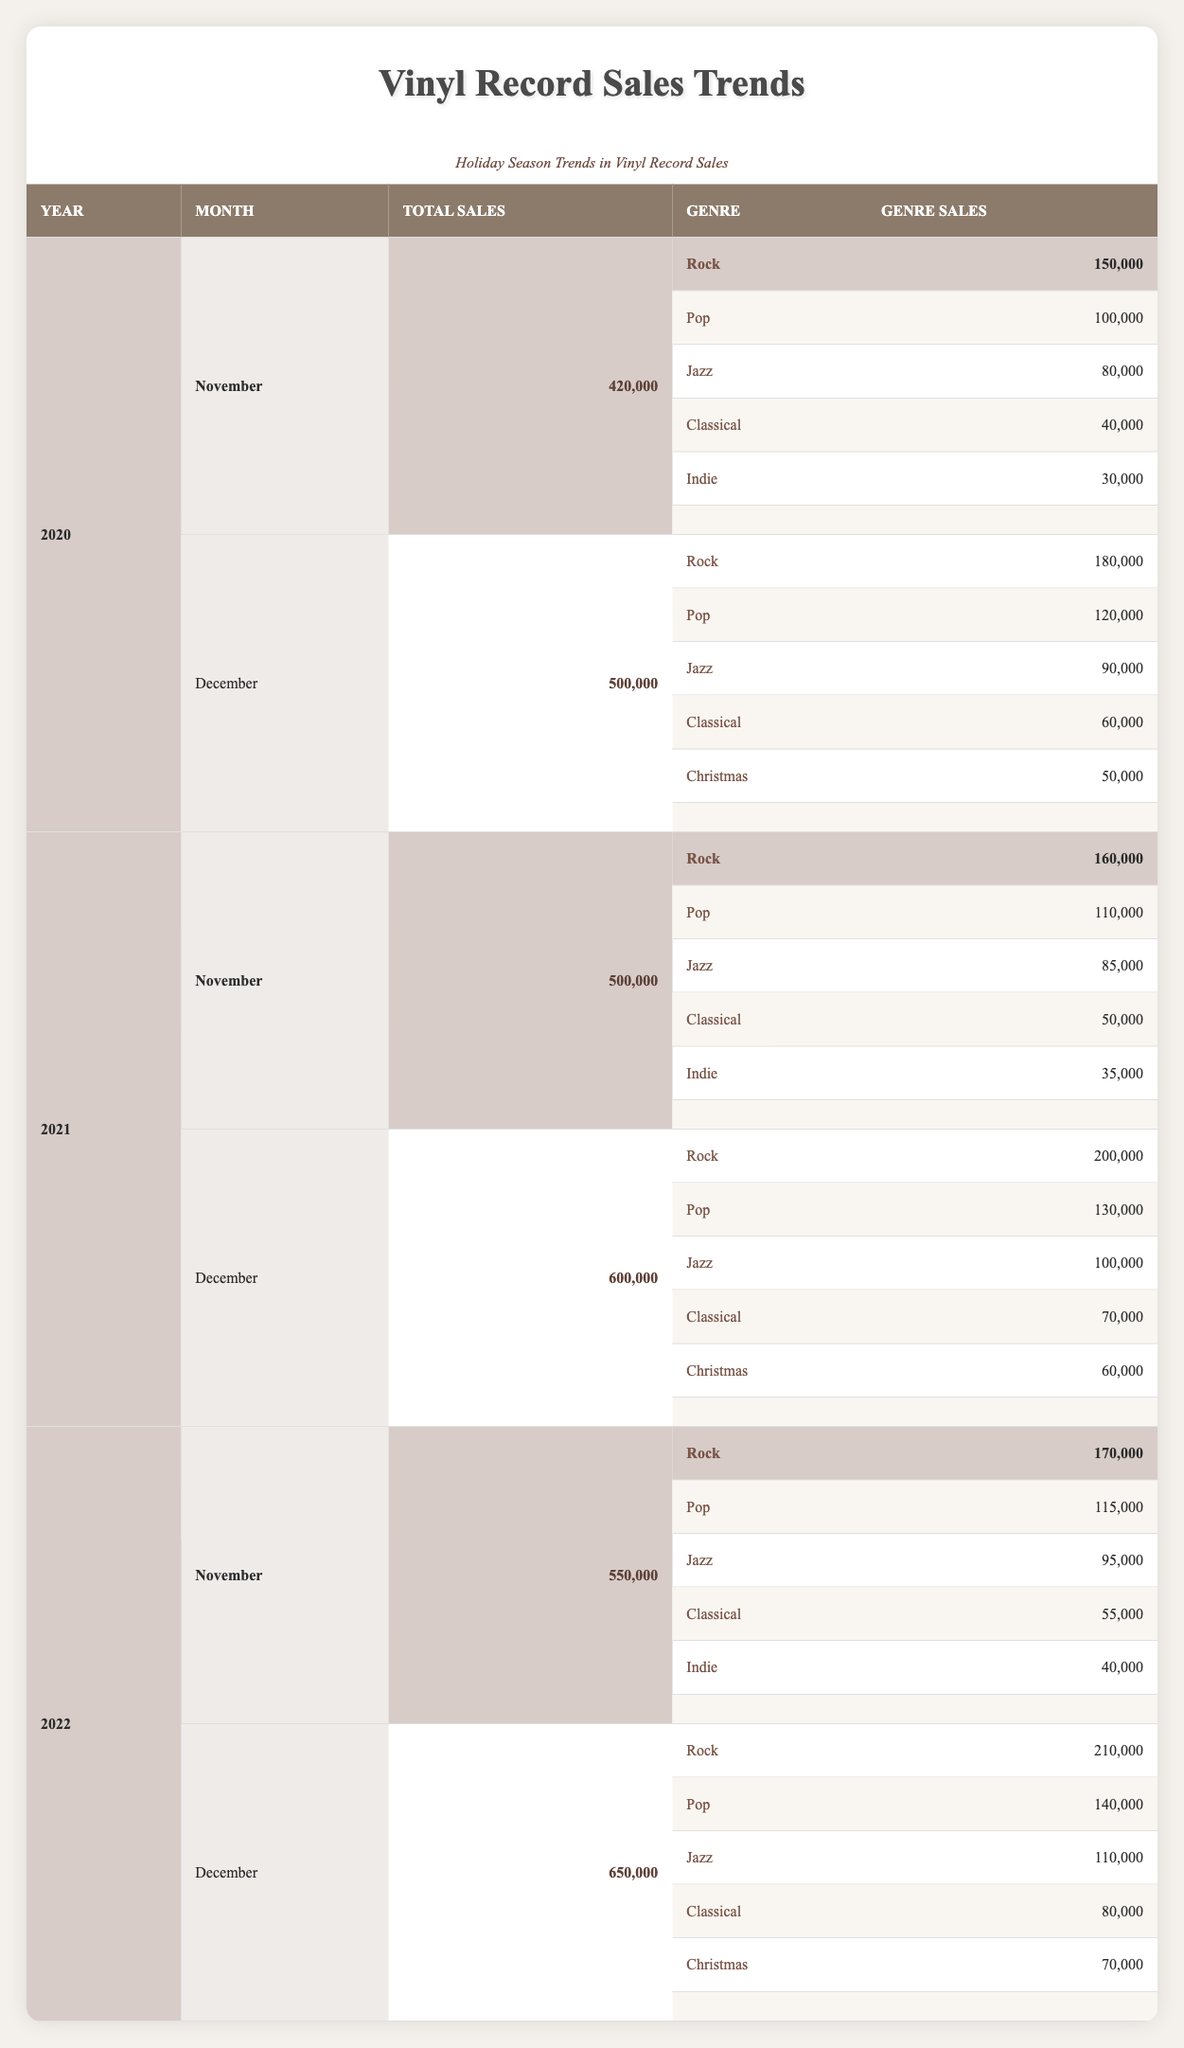What was the total vinyl record sales in December 2021? In December 2021, the row corresponding to this month under the year 2021 shows total sales of 600,000.
Answer: 600,000 Which genre had the highest sales in November 2022? Looking at November 2022, the highest sales listed are for Rock, with 170,000 sales.
Answer: Rock Was there an increase in total sales from December 2020 to December 2021? In December 2020, total sales were 500,000, and in December 2021, they increased to 600,000. Therefore, there was an increase of 100,000.
Answer: Yes What is the total sales of classical genre across all months in 2022? The classical genre had sales of 55,000 in November and 80,000 in December 2022. Summing these gives 55,000 + 80,000 = 135,000.
Answer: 135,000 Did Christmas genre sales exceed 60,000 in December 2022? In December 2022, Christmas genre sales were 70,000, which is greater than 60,000.
Answer: Yes What was the average vinyl sales per month for Pop genre in 2021? For Pop in 2021, sales were 110,000 in November and 130,000 in December. The average is (110,000 + 130,000) / 2 = 120,000.
Answer: 120,000 How much did total vinyl sales increase from November 2020 to November 2021? In November 2020, total sales were 420,000 and in November 2021 it was 500,000. The increase is 500,000 - 420,000 = 80,000.
Answer: 80,000 Which genre saw a sales decrease from November to December in 2020? In November 2020, Jazz had 80,000 sales and decreased to 90,000 in December, while Classical sales increased from 40,000 to 60,000; hence, there was no decrease for any genre.
Answer: None What is the total sales of Rock genre in December across the three years? In December 2020, Rock sales were 180,000; in December 2021, it was 200,000; and in December 2022, it was 210,000. Totaling these gives 180,000 + 200,000 + 210,000 = 590,000.
Answer: 590,000 